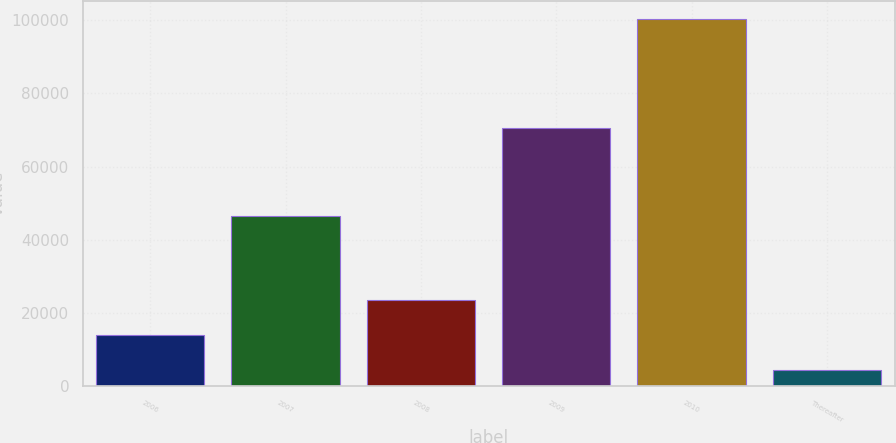<chart> <loc_0><loc_0><loc_500><loc_500><bar_chart><fcel>2006<fcel>2007<fcel>2008<fcel>2009<fcel>2010<fcel>Thereafter<nl><fcel>13998.8<fcel>46417<fcel>23586.6<fcel>70491<fcel>100289<fcel>4411<nl></chart> 